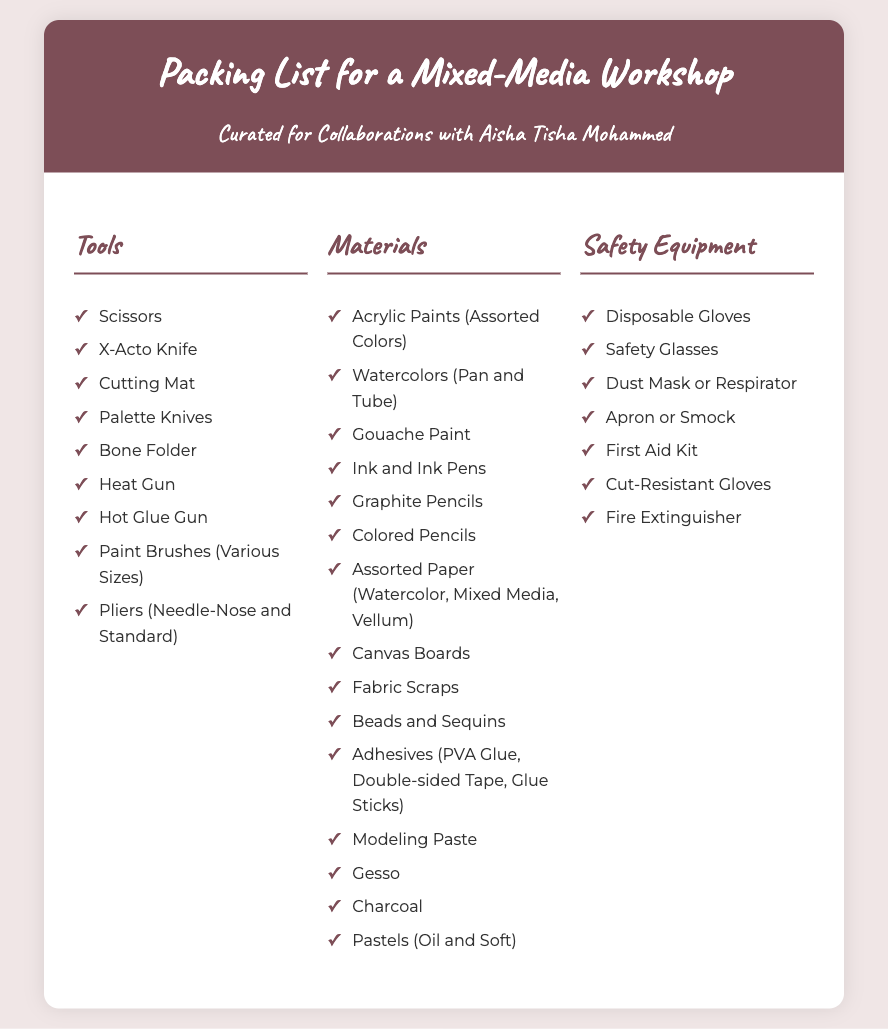What are the tools listed for the mixed-media workshop? The document provides a specific list of tools necessary for the workshop, including items like scissors, X-Acto knife, and hot glue gun.
Answer: Scissors, X-Acto Knife, Cutting Mat, Palette Knives, Bone Folder, Heat Gun, Hot Glue Gun, Paint Brushes (Various Sizes), Pliers (Needle-Nose and Standard) How many types of safety equipment are mentioned? The document lists various equipment required for safety, including disposable gloves and safety glasses, totaling the number mentioned.
Answer: Seven What type of paint is included in the materials? The list of materials covers different types of paints, such as acrylic paints and watercolors, providing insight into the workshop's painting supplies.
Answer: Acrylic Paints, Watercolors, Gouache Paint Is a first aid kit included in the packing list? The presence of a first aid kit is specifically noted under safety equipment, highlighting its importance in the workshop context.
Answer: Yes Which category includes adhesives? The document organizes items into categories, and adhesives specifically fall under the materials section, indicating their relevance in mixed-media creation.
Answer: Materials 